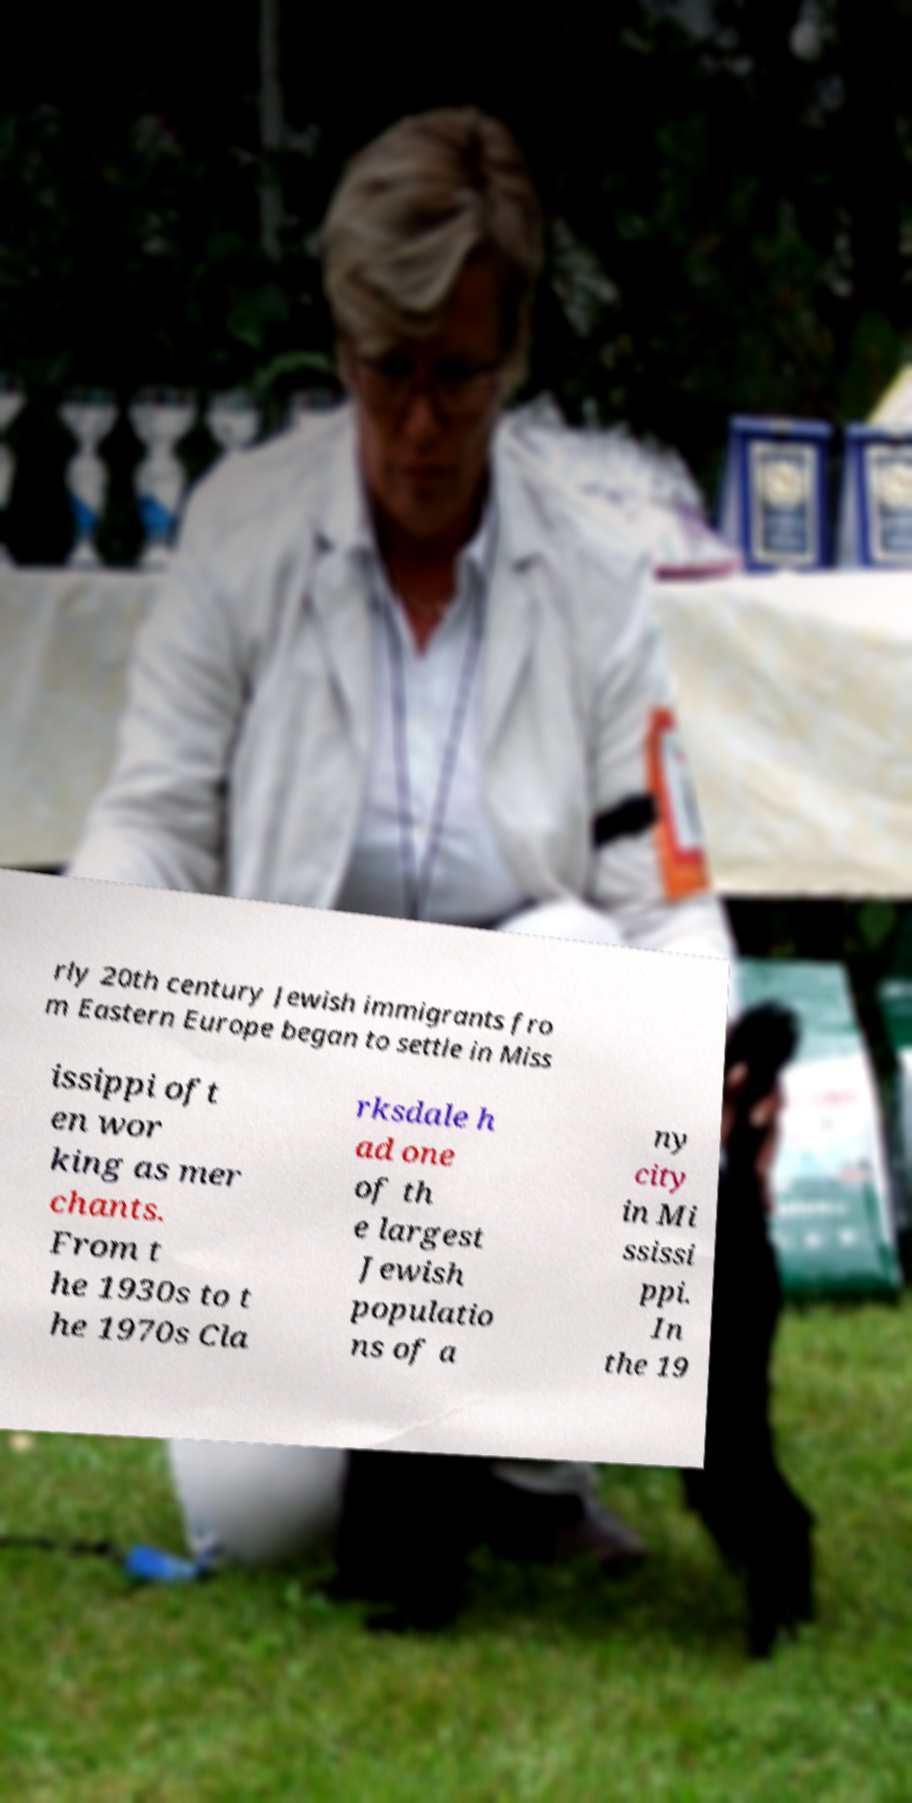There's text embedded in this image that I need extracted. Can you transcribe it verbatim? rly 20th century Jewish immigrants fro m Eastern Europe began to settle in Miss issippi oft en wor king as mer chants. From t he 1930s to t he 1970s Cla rksdale h ad one of th e largest Jewish populatio ns of a ny city in Mi ssissi ppi. In the 19 